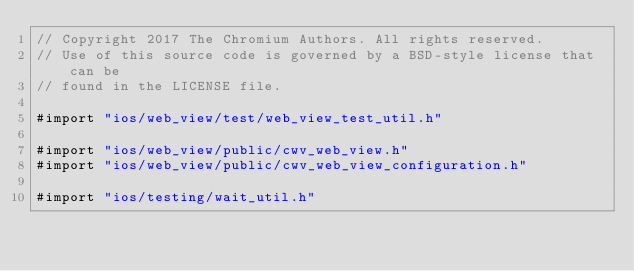Convert code to text. <code><loc_0><loc_0><loc_500><loc_500><_ObjectiveC_>// Copyright 2017 The Chromium Authors. All rights reserved.
// Use of this source code is governed by a BSD-style license that can be
// found in the LICENSE file.

#import "ios/web_view/test/web_view_test_util.h"

#import "ios/web_view/public/cwv_web_view.h"
#import "ios/web_view/public/cwv_web_view_configuration.h"

#import "ios/testing/wait_util.h"
</code> 